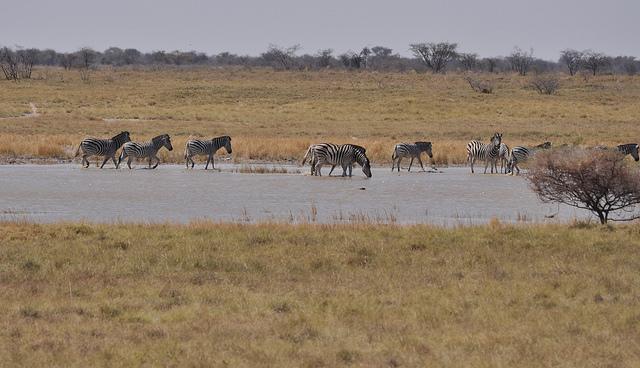Are these zebras going for a walk?
Quick response, please. No. Is this a game park?
Write a very short answer. No. Are they in the water?
Be succinct. Yes. Is something chasing the zebras?
Concise answer only. No. Is that one herd of zebras?
Answer briefly. Yes. Are all these creatures natural friends?
Quick response, please. Yes. 